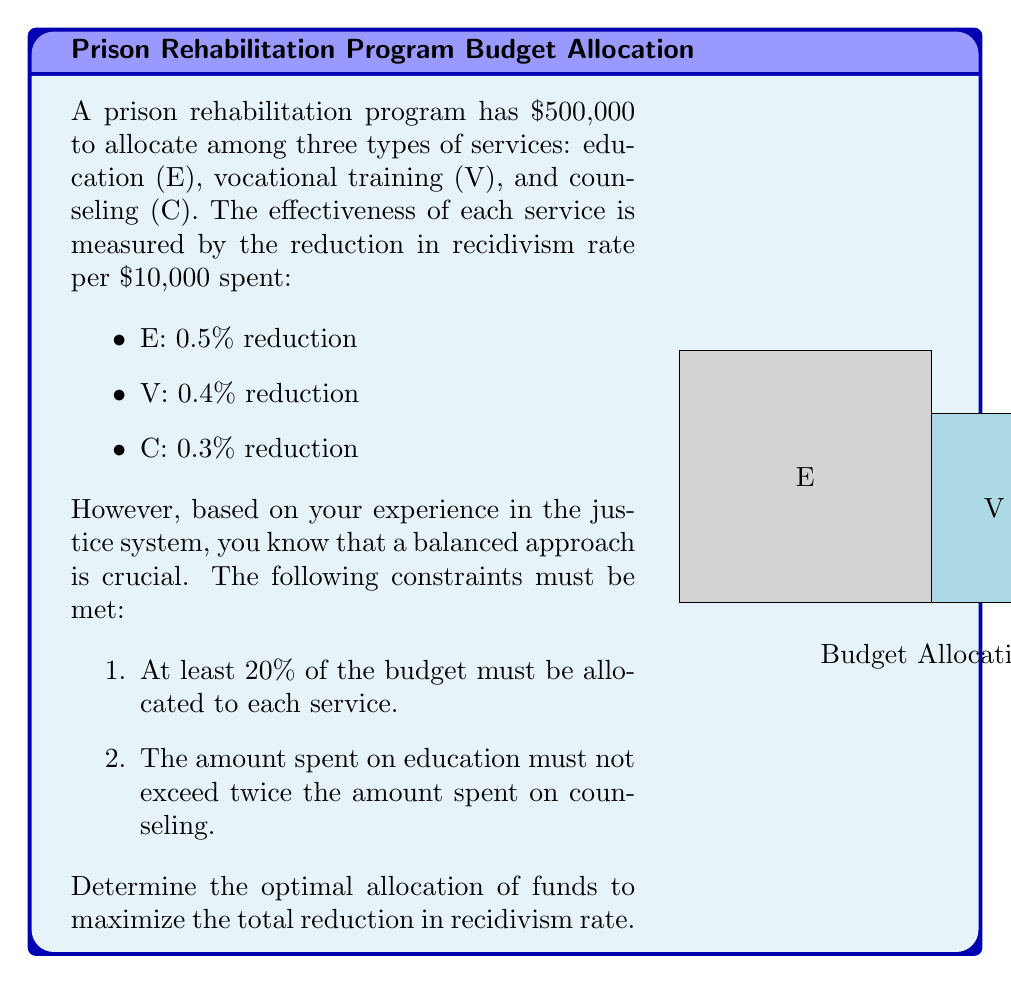Show me your answer to this math problem. Let's approach this step-by-step using linear programming:

1) Define variables:
   Let $x_E$, $x_V$, and $x_C$ be the amounts (in $10,000s) allocated to education, vocational training, and counseling respectively.

2) Objective function:
   Maximize $Z = 0.5x_E + 0.4x_V + 0.3x_C$

3) Constraints:
   a) Total budget: $x_E + x_V + x_C = 50$ (since $500,000 / $10,000 = 50)
   b) Minimum 20% for each: $x_E \geq 10$, $x_V \geq 10$, $x_C \geq 10$
   c) Education not exceeding twice counseling: $x_E \leq 2x_C$

4) Non-negativity: $x_E, x_V, x_C \geq 0$

5) Solve using the simplex method or a solver. The optimal solution is:
   $x_E = 20$, $x_V = 20$, $x_C = 10$

6) This translates to:
   Education: $200,000
   Vocational Training: $200,000
   Counseling: $100,000

7) The maximum reduction in recidivism rate is:
   $0.5(20) + 0.4(20) + 0.3(10) = 10 + 8 + 3 = 21\%$
Answer: E: $200,000, V: $200,000, C: $100,000; 21% reduction 